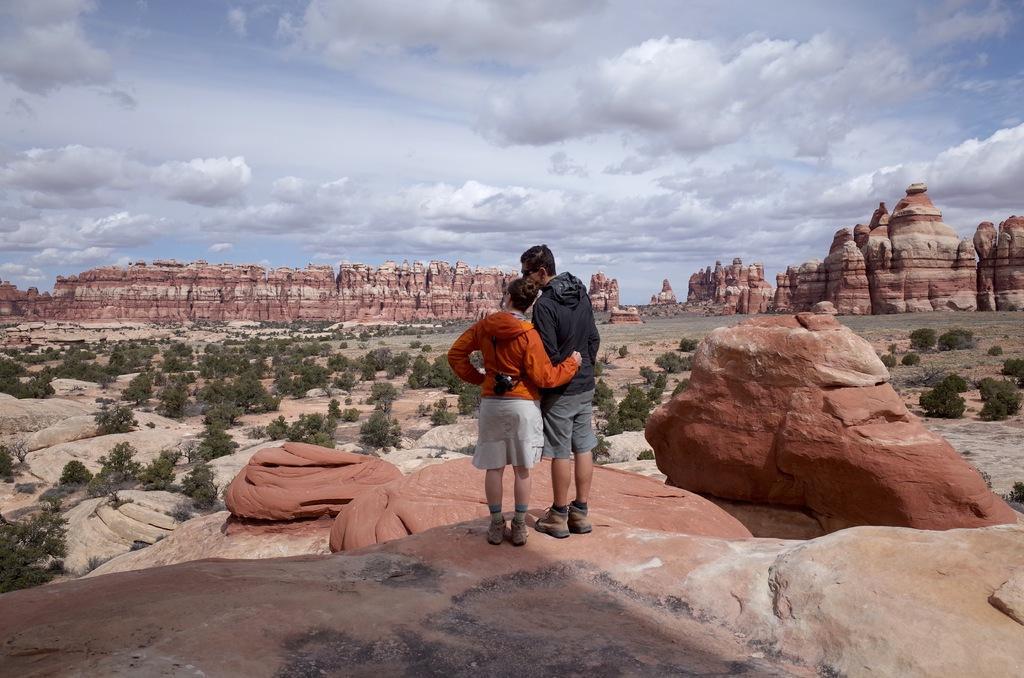Please provide a concise description of this image. There is one woman and a man standing on the rock as we can see at the bottom of this image. We can see trees and mountains in the background. There is a cloudy sky at the top of this image. 